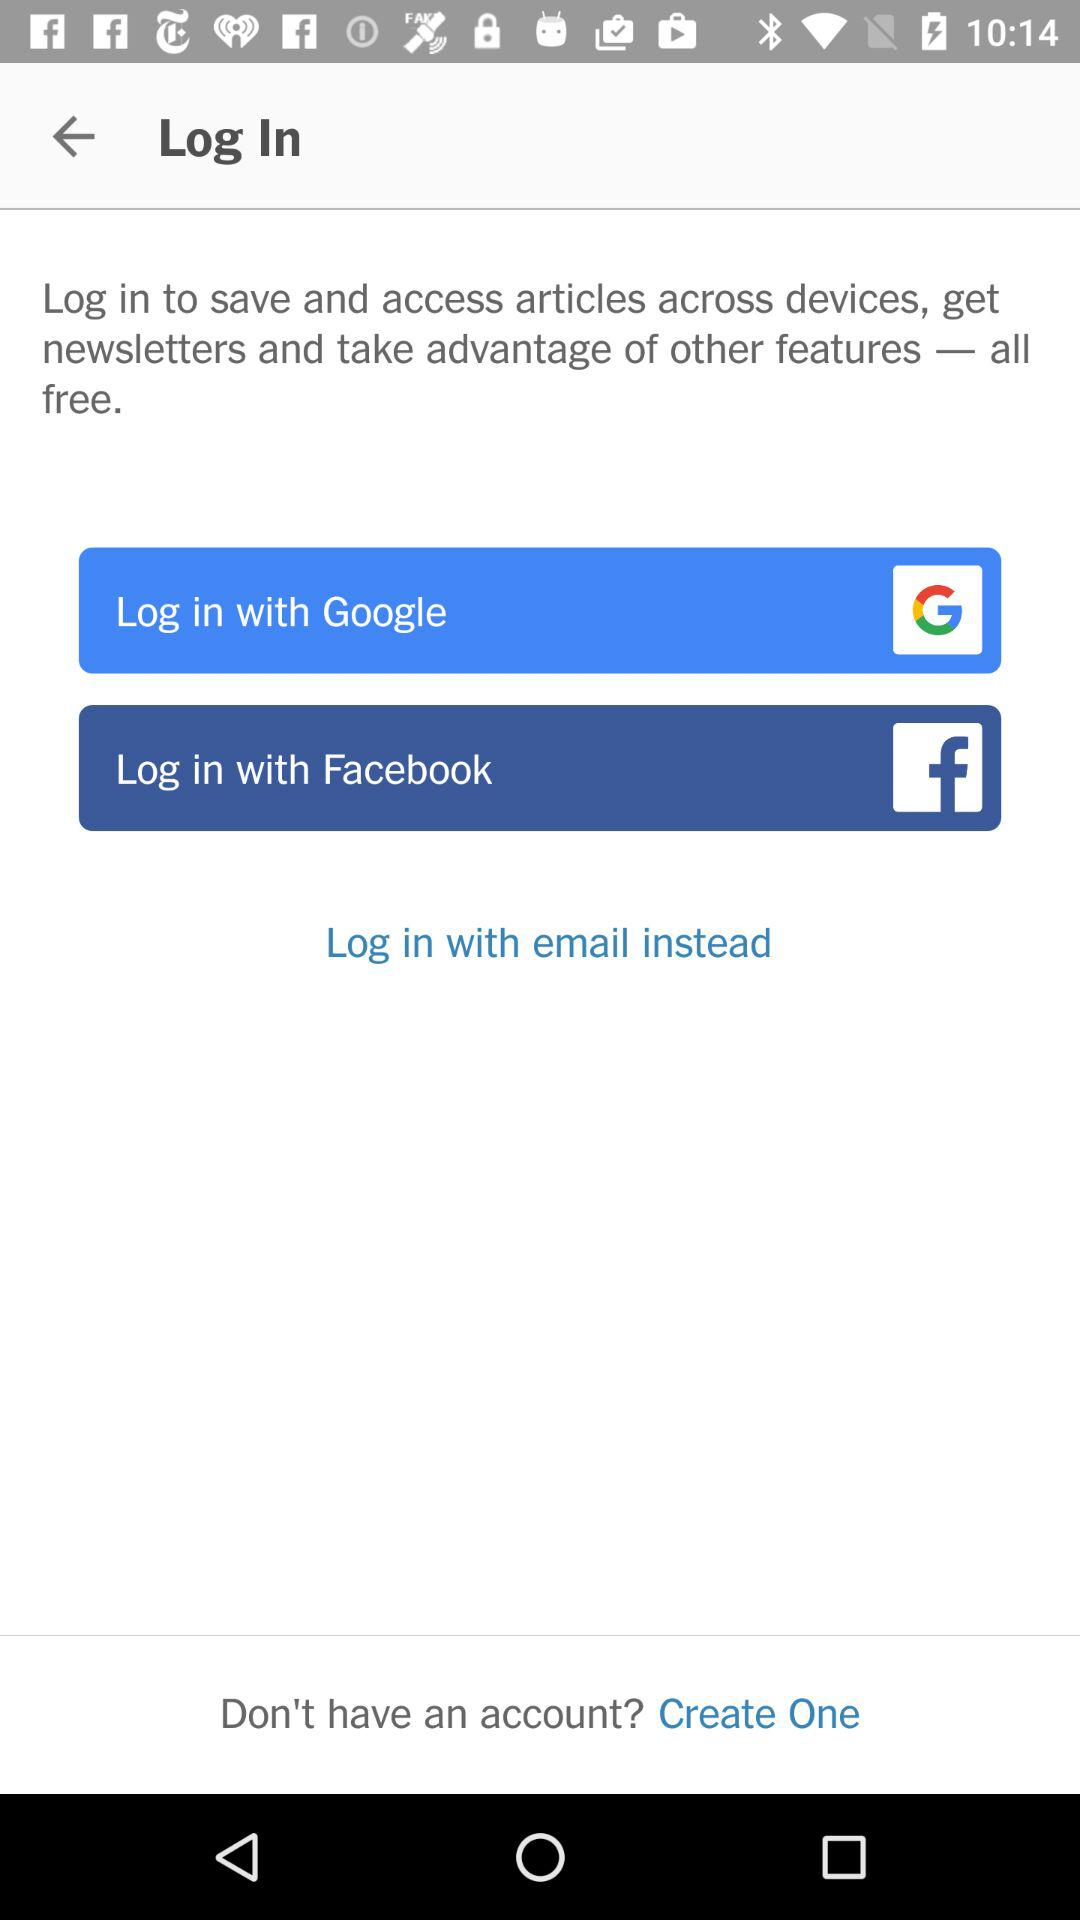How many options are available for signing in?
Answer the question using a single word or phrase. 3 